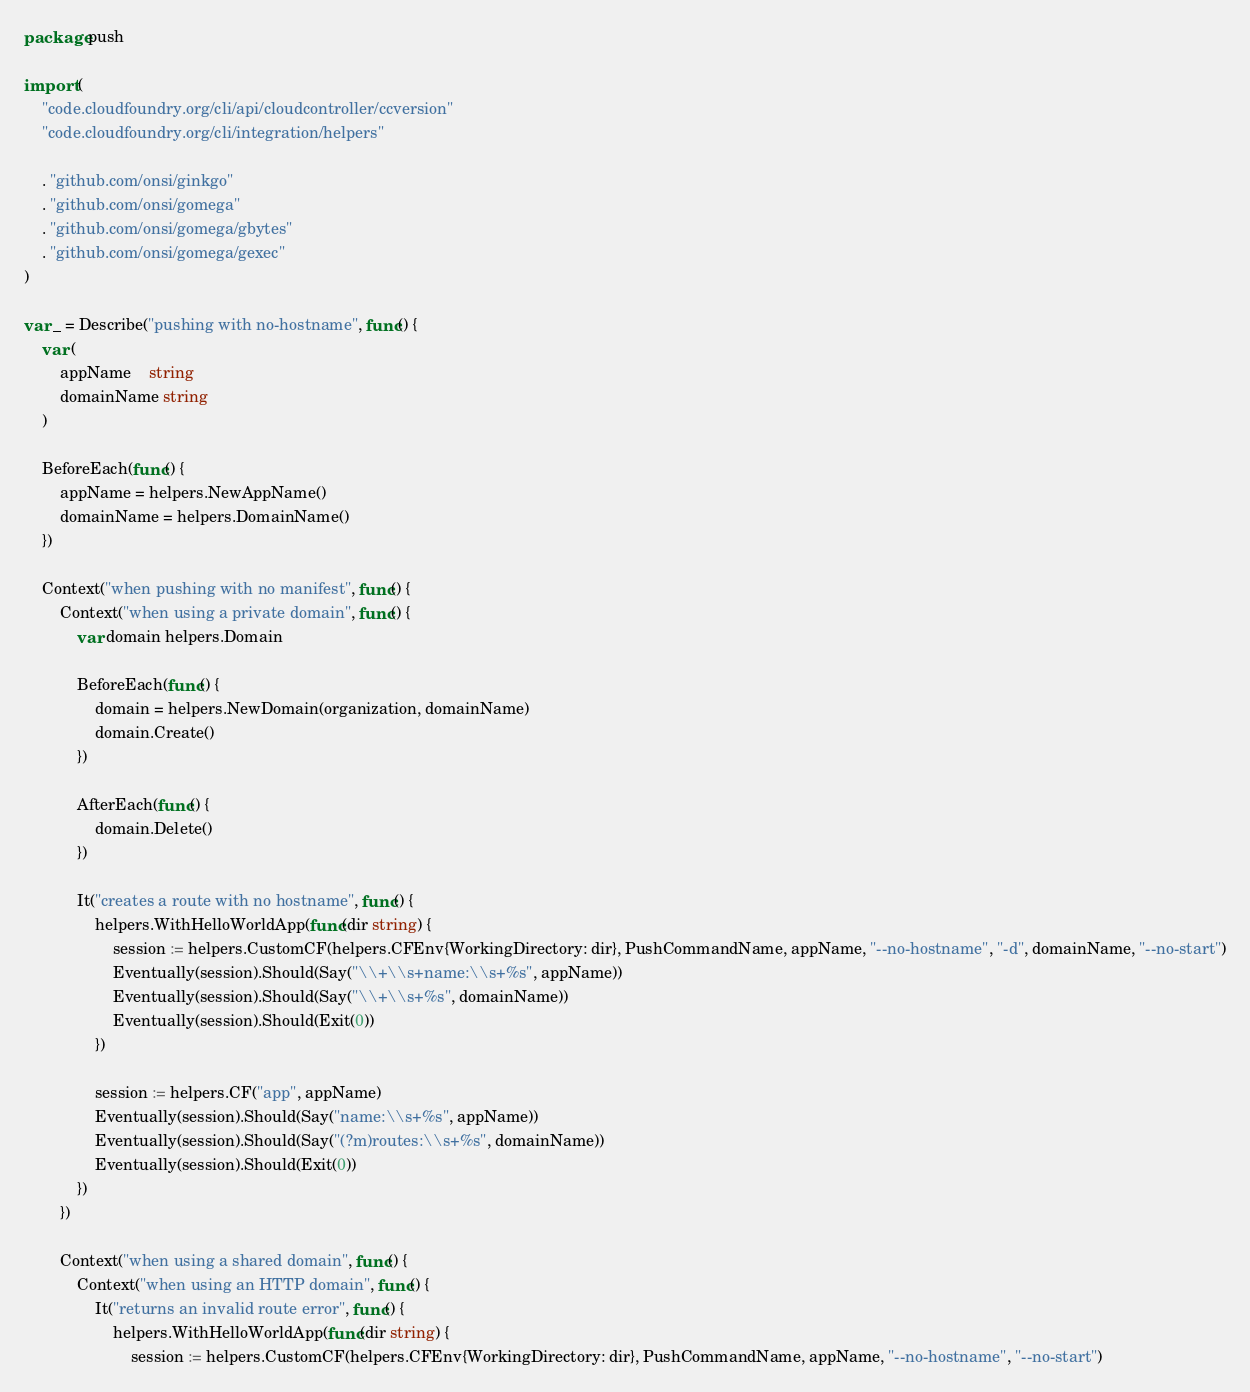Convert code to text. <code><loc_0><loc_0><loc_500><loc_500><_Go_>package push

import (
	"code.cloudfoundry.org/cli/api/cloudcontroller/ccversion"
	"code.cloudfoundry.org/cli/integration/helpers"

	. "github.com/onsi/ginkgo"
	. "github.com/onsi/gomega"
	. "github.com/onsi/gomega/gbytes"
	. "github.com/onsi/gomega/gexec"
)

var _ = Describe("pushing with no-hostname", func() {
	var (
		appName    string
		domainName string
	)

	BeforeEach(func() {
		appName = helpers.NewAppName()
		domainName = helpers.DomainName()
	})

	Context("when pushing with no manifest", func() {
		Context("when using a private domain", func() {
			var domain helpers.Domain

			BeforeEach(func() {
				domain = helpers.NewDomain(organization, domainName)
				domain.Create()
			})

			AfterEach(func() {
				domain.Delete()
			})

			It("creates a route with no hostname", func() {
				helpers.WithHelloWorldApp(func(dir string) {
					session := helpers.CustomCF(helpers.CFEnv{WorkingDirectory: dir}, PushCommandName, appName, "--no-hostname", "-d", domainName, "--no-start")
					Eventually(session).Should(Say("\\+\\s+name:\\s+%s", appName))
					Eventually(session).Should(Say("\\+\\s+%s", domainName))
					Eventually(session).Should(Exit(0))
				})

				session := helpers.CF("app", appName)
				Eventually(session).Should(Say("name:\\s+%s", appName))
				Eventually(session).Should(Say("(?m)routes:\\s+%s", domainName))
				Eventually(session).Should(Exit(0))
			})
		})

		Context("when using a shared domain", func() {
			Context("when using an HTTP domain", func() {
				It("returns an invalid route error", func() {
					helpers.WithHelloWorldApp(func(dir string) {
						session := helpers.CustomCF(helpers.CFEnv{WorkingDirectory: dir}, PushCommandName, appName, "--no-hostname", "--no-start")</code> 